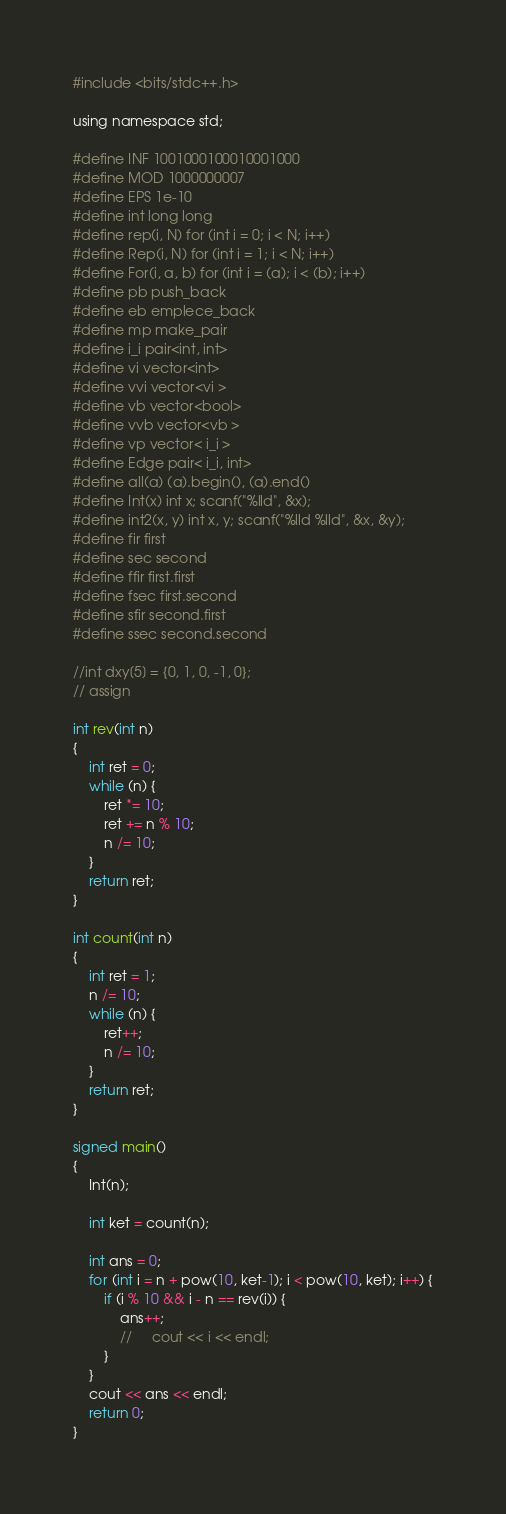Convert code to text. <code><loc_0><loc_0><loc_500><loc_500><_C_>#include <bits/stdc++.h>

using namespace std;

#define INF 1001000100010001000
#define MOD 1000000007
#define EPS 1e-10
#define int long long
#define rep(i, N) for (int i = 0; i < N; i++)
#define Rep(i, N) for (int i = 1; i < N; i++)
#define For(i, a, b) for (int i = (a); i < (b); i++)
#define pb push_back
#define eb emplece_back
#define mp make_pair
#define i_i pair<int, int>
#define vi vector<int>
#define vvi vector<vi >
#define vb vector<bool>
#define vvb vector<vb >
#define vp vector< i_i >
#define Edge pair< i_i, int>
#define all(a) (a).begin(), (a).end()
#define Int(x) int x; scanf("%lld", &x);
#define int2(x, y) int x, y; scanf("%lld %lld", &x, &y);
#define fir first
#define sec second
#define ffir first.first
#define fsec first.second
#define sfir second.first
#define ssec second.second
 
//int dxy[5] = {0, 1, 0, -1, 0};
// assign

int rev(int n)
{
    int ret = 0;
    while (n) {
        ret *= 10;
        ret += n % 10;
        n /= 10;
    }
    return ret;
}

int count(int n)
{
    int ret = 1;
    n /= 10;
    while (n) {
        ret++;
        n /= 10;
    }
    return ret;
}

signed main()
{
    Int(n);

    int ket = count(n);

    int ans = 0;
    for (int i = n + pow(10, ket-1); i < pow(10, ket); i++) {
        if (i % 10 && i - n == rev(i)) {
            ans++;
            //     cout << i << endl;
        }
    }
    cout << ans << endl;
    return 0;
}

</code> 